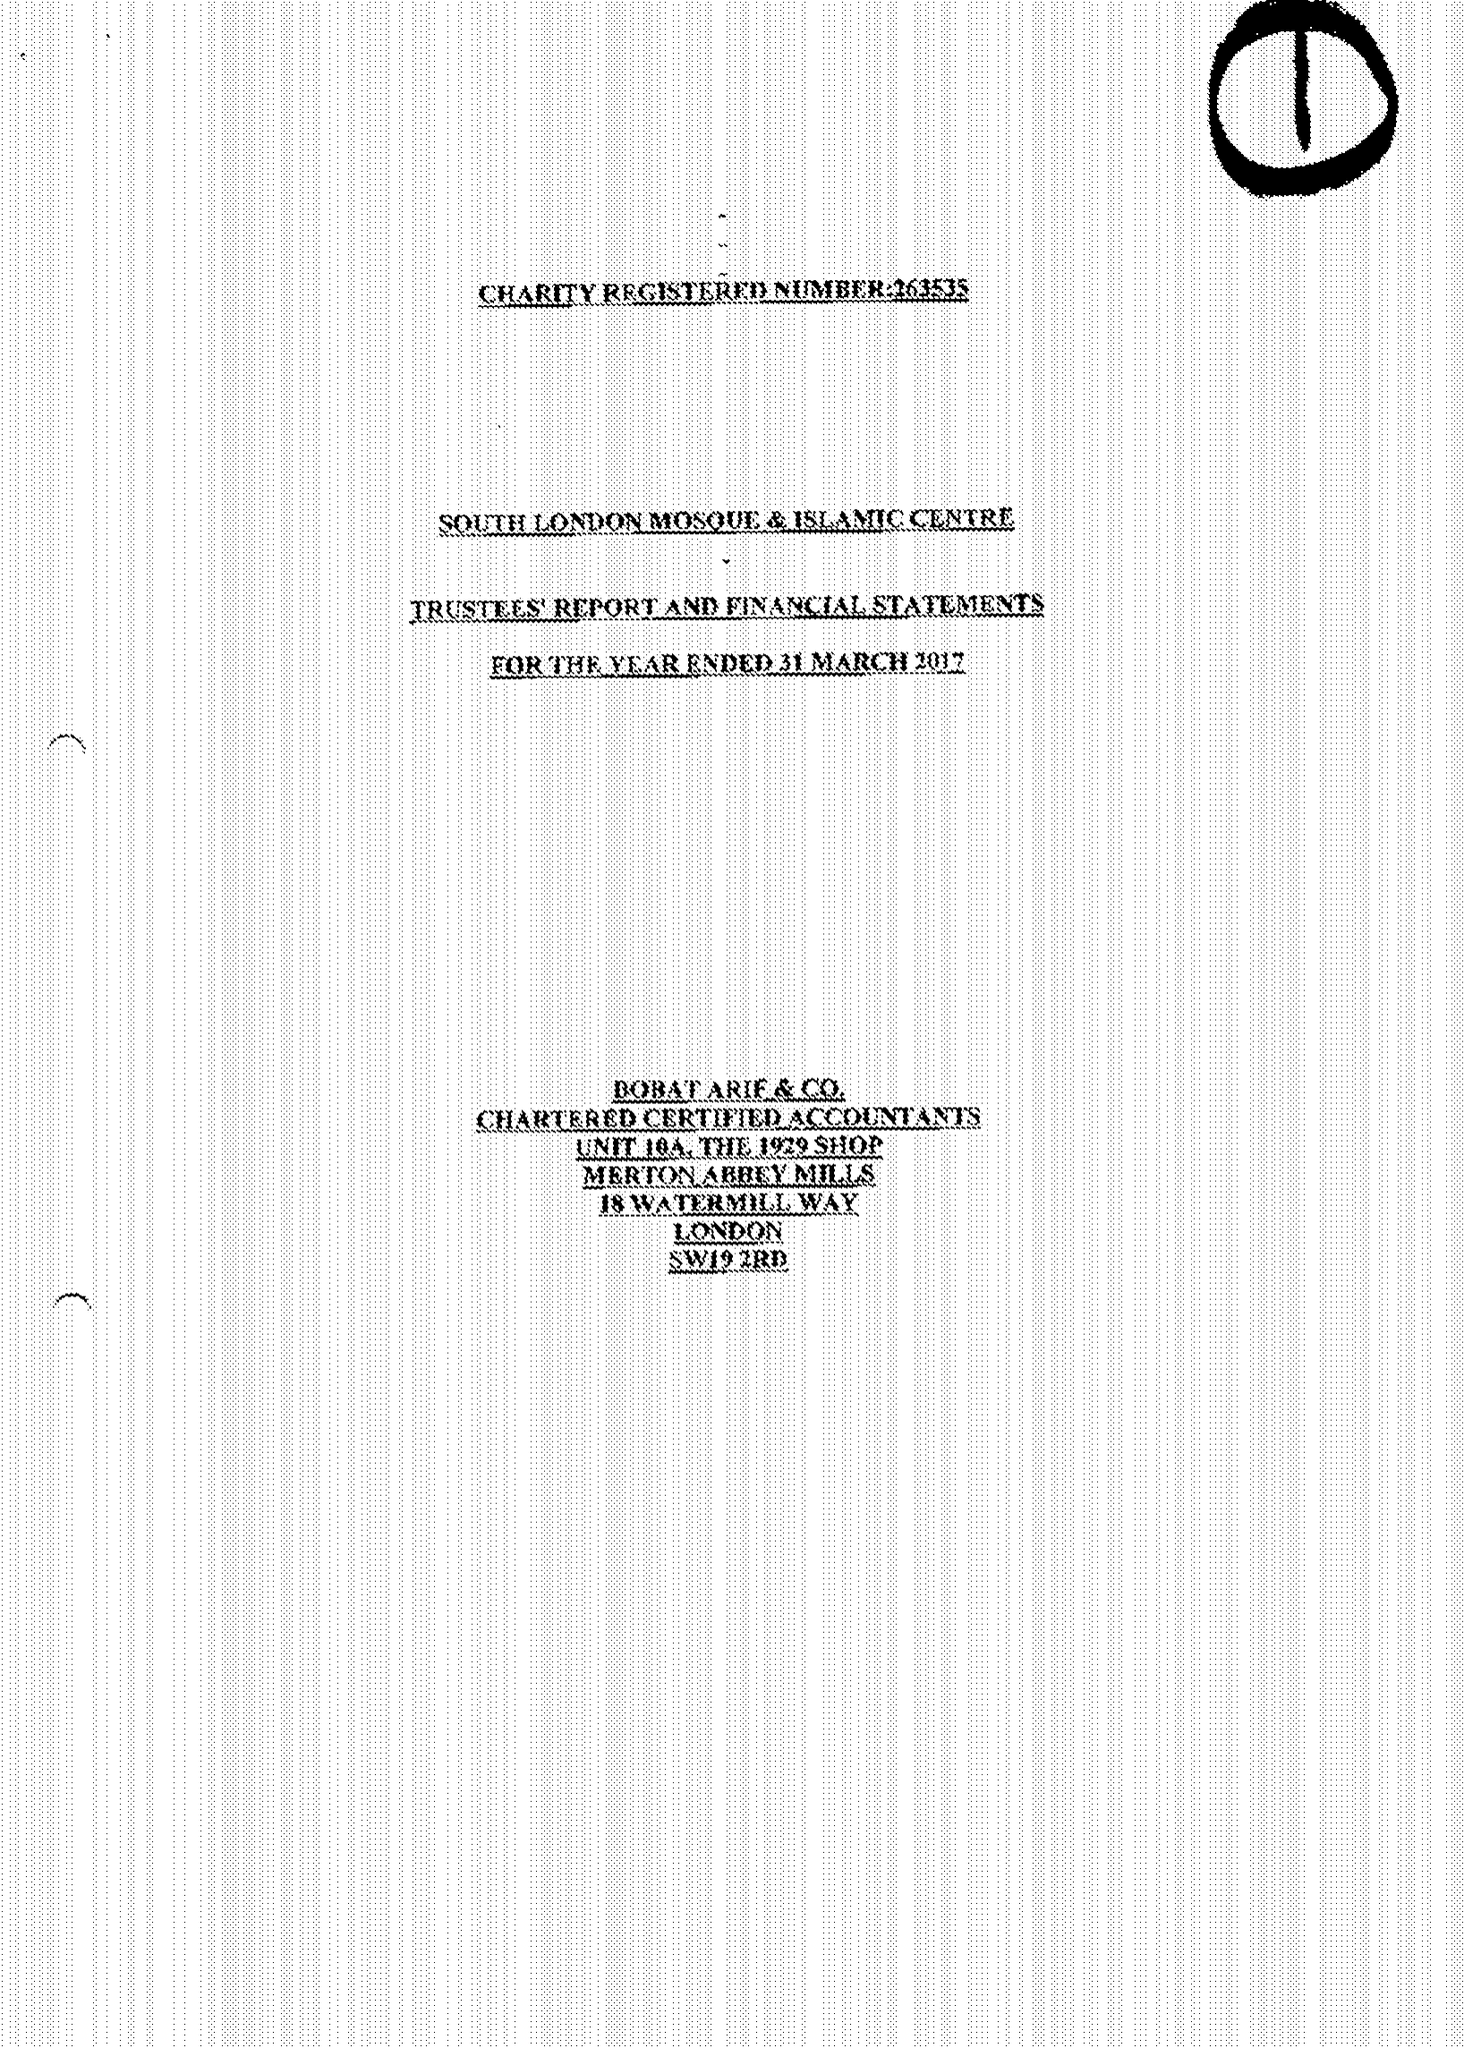What is the value for the address__postcode?
Answer the question using a single word or phrase. SW16 6NN 